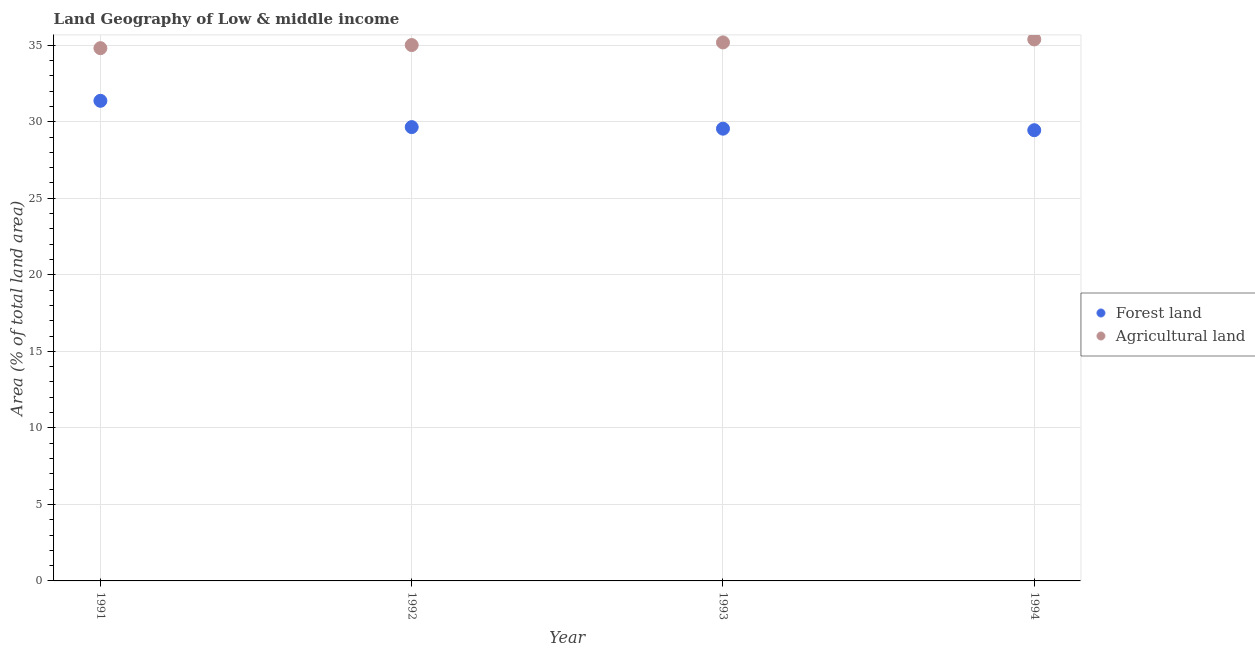Is the number of dotlines equal to the number of legend labels?
Your response must be concise. Yes. What is the percentage of land area under agriculture in 1993?
Make the answer very short. 35.18. Across all years, what is the maximum percentage of land area under forests?
Offer a terse response. 31.37. Across all years, what is the minimum percentage of land area under forests?
Offer a very short reply. 29.45. What is the total percentage of land area under agriculture in the graph?
Make the answer very short. 140.37. What is the difference between the percentage of land area under agriculture in 1993 and that in 1994?
Make the answer very short. -0.2. What is the difference between the percentage of land area under forests in 1994 and the percentage of land area under agriculture in 1991?
Offer a very short reply. -5.36. What is the average percentage of land area under forests per year?
Your answer should be compact. 30. In the year 1994, what is the difference between the percentage of land area under agriculture and percentage of land area under forests?
Your answer should be very brief. 5.93. In how many years, is the percentage of land area under agriculture greater than 17 %?
Ensure brevity in your answer.  4. What is the ratio of the percentage of land area under forests in 1992 to that in 1994?
Make the answer very short. 1.01. Is the percentage of land area under agriculture in 1991 less than that in 1993?
Your answer should be very brief. Yes. Is the difference between the percentage of land area under forests in 1993 and 1994 greater than the difference between the percentage of land area under agriculture in 1993 and 1994?
Make the answer very short. Yes. What is the difference between the highest and the second highest percentage of land area under forests?
Provide a short and direct response. 1.72. What is the difference between the highest and the lowest percentage of land area under agriculture?
Your answer should be very brief. 0.57. In how many years, is the percentage of land area under forests greater than the average percentage of land area under forests taken over all years?
Give a very brief answer. 1. Is the percentage of land area under agriculture strictly greater than the percentage of land area under forests over the years?
Your answer should be very brief. Yes. Is the percentage of land area under forests strictly less than the percentage of land area under agriculture over the years?
Your response must be concise. Yes. How many dotlines are there?
Ensure brevity in your answer.  2. How many years are there in the graph?
Provide a succinct answer. 4. What is the difference between two consecutive major ticks on the Y-axis?
Your answer should be compact. 5. Are the values on the major ticks of Y-axis written in scientific E-notation?
Provide a succinct answer. No. Does the graph contain any zero values?
Your answer should be very brief. No. Does the graph contain grids?
Your answer should be compact. Yes. How are the legend labels stacked?
Offer a very short reply. Vertical. What is the title of the graph?
Your answer should be compact. Land Geography of Low & middle income. Does "Adolescent fertility rate" appear as one of the legend labels in the graph?
Your response must be concise. No. What is the label or title of the X-axis?
Provide a succinct answer. Year. What is the label or title of the Y-axis?
Make the answer very short. Area (% of total land area). What is the Area (% of total land area) in Forest land in 1991?
Provide a succinct answer. 31.37. What is the Area (% of total land area) in Agricultural land in 1991?
Make the answer very short. 34.81. What is the Area (% of total land area) in Forest land in 1992?
Offer a terse response. 29.65. What is the Area (% of total land area) in Agricultural land in 1992?
Offer a very short reply. 35.01. What is the Area (% of total land area) in Forest land in 1993?
Give a very brief answer. 29.55. What is the Area (% of total land area) of Agricultural land in 1993?
Give a very brief answer. 35.18. What is the Area (% of total land area) of Forest land in 1994?
Make the answer very short. 29.45. What is the Area (% of total land area) of Agricultural land in 1994?
Make the answer very short. 35.38. Across all years, what is the maximum Area (% of total land area) in Forest land?
Ensure brevity in your answer.  31.37. Across all years, what is the maximum Area (% of total land area) in Agricultural land?
Offer a very short reply. 35.38. Across all years, what is the minimum Area (% of total land area) in Forest land?
Offer a very short reply. 29.45. Across all years, what is the minimum Area (% of total land area) of Agricultural land?
Your answer should be very brief. 34.81. What is the total Area (% of total land area) of Forest land in the graph?
Your response must be concise. 120.01. What is the total Area (% of total land area) in Agricultural land in the graph?
Provide a succinct answer. 140.37. What is the difference between the Area (% of total land area) of Forest land in 1991 and that in 1992?
Offer a terse response. 1.72. What is the difference between the Area (% of total land area) in Agricultural land in 1991 and that in 1992?
Offer a very short reply. -0.2. What is the difference between the Area (% of total land area) of Forest land in 1991 and that in 1993?
Offer a very short reply. 1.82. What is the difference between the Area (% of total land area) in Agricultural land in 1991 and that in 1993?
Your answer should be very brief. -0.38. What is the difference between the Area (% of total land area) in Forest land in 1991 and that in 1994?
Ensure brevity in your answer.  1.92. What is the difference between the Area (% of total land area) of Agricultural land in 1991 and that in 1994?
Your answer should be very brief. -0.57. What is the difference between the Area (% of total land area) in Forest land in 1992 and that in 1993?
Offer a terse response. 0.1. What is the difference between the Area (% of total land area) of Agricultural land in 1992 and that in 1993?
Your response must be concise. -0.17. What is the difference between the Area (% of total land area) in Forest land in 1992 and that in 1994?
Offer a terse response. 0.2. What is the difference between the Area (% of total land area) in Agricultural land in 1992 and that in 1994?
Offer a very short reply. -0.37. What is the difference between the Area (% of total land area) of Forest land in 1993 and that in 1994?
Provide a short and direct response. 0.1. What is the difference between the Area (% of total land area) in Agricultural land in 1993 and that in 1994?
Give a very brief answer. -0.2. What is the difference between the Area (% of total land area) in Forest land in 1991 and the Area (% of total land area) in Agricultural land in 1992?
Offer a terse response. -3.64. What is the difference between the Area (% of total land area) of Forest land in 1991 and the Area (% of total land area) of Agricultural land in 1993?
Your response must be concise. -3.81. What is the difference between the Area (% of total land area) of Forest land in 1991 and the Area (% of total land area) of Agricultural land in 1994?
Keep it short and to the point. -4.01. What is the difference between the Area (% of total land area) of Forest land in 1992 and the Area (% of total land area) of Agricultural land in 1993?
Make the answer very short. -5.53. What is the difference between the Area (% of total land area) of Forest land in 1992 and the Area (% of total land area) of Agricultural land in 1994?
Provide a short and direct response. -5.73. What is the difference between the Area (% of total land area) in Forest land in 1993 and the Area (% of total land area) in Agricultural land in 1994?
Give a very brief answer. -5.83. What is the average Area (% of total land area) in Forest land per year?
Ensure brevity in your answer.  30. What is the average Area (% of total land area) in Agricultural land per year?
Offer a very short reply. 35.09. In the year 1991, what is the difference between the Area (% of total land area) of Forest land and Area (% of total land area) of Agricultural land?
Your answer should be compact. -3.44. In the year 1992, what is the difference between the Area (% of total land area) of Forest land and Area (% of total land area) of Agricultural land?
Give a very brief answer. -5.36. In the year 1993, what is the difference between the Area (% of total land area) of Forest land and Area (% of total land area) of Agricultural land?
Give a very brief answer. -5.63. In the year 1994, what is the difference between the Area (% of total land area) of Forest land and Area (% of total land area) of Agricultural land?
Your response must be concise. -5.93. What is the ratio of the Area (% of total land area) of Forest land in 1991 to that in 1992?
Your answer should be compact. 1.06. What is the ratio of the Area (% of total land area) of Forest land in 1991 to that in 1993?
Your response must be concise. 1.06. What is the ratio of the Area (% of total land area) of Agricultural land in 1991 to that in 1993?
Give a very brief answer. 0.99. What is the ratio of the Area (% of total land area) of Forest land in 1991 to that in 1994?
Provide a short and direct response. 1.07. What is the ratio of the Area (% of total land area) of Agricultural land in 1991 to that in 1994?
Make the answer very short. 0.98. What is the ratio of the Area (% of total land area) in Forest land in 1992 to that in 1993?
Your answer should be compact. 1. What is the ratio of the Area (% of total land area) of Agricultural land in 1992 to that in 1993?
Your answer should be very brief. 1. What is the ratio of the Area (% of total land area) of Forest land in 1992 to that in 1994?
Offer a very short reply. 1.01. What is the ratio of the Area (% of total land area) in Agricultural land in 1992 to that in 1994?
Provide a succinct answer. 0.99. What is the ratio of the Area (% of total land area) in Agricultural land in 1993 to that in 1994?
Your answer should be compact. 0.99. What is the difference between the highest and the second highest Area (% of total land area) in Forest land?
Offer a terse response. 1.72. What is the difference between the highest and the second highest Area (% of total land area) of Agricultural land?
Offer a very short reply. 0.2. What is the difference between the highest and the lowest Area (% of total land area) in Forest land?
Ensure brevity in your answer.  1.92. What is the difference between the highest and the lowest Area (% of total land area) of Agricultural land?
Your answer should be compact. 0.57. 